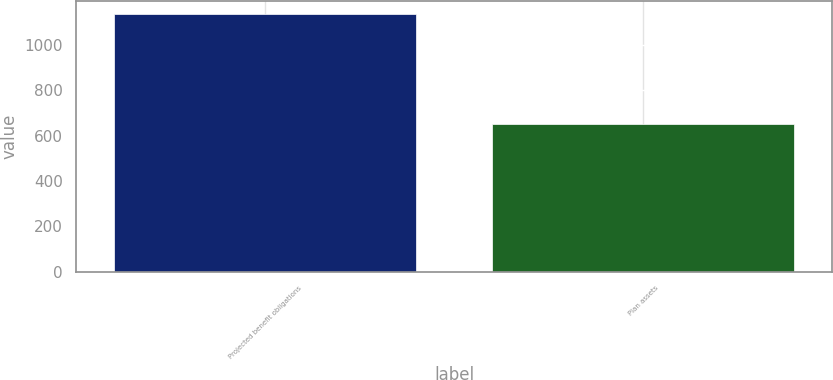<chart> <loc_0><loc_0><loc_500><loc_500><bar_chart><fcel>Projected benefit obligations<fcel>Plan assets<nl><fcel>1137<fcel>649<nl></chart> 